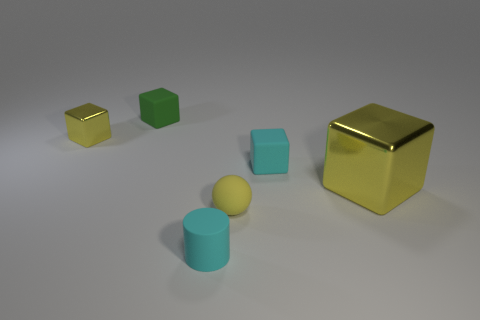Subtract 1 blocks. How many blocks are left? 3 Add 3 tiny cyan things. How many objects exist? 9 Subtract all spheres. How many objects are left? 5 Add 4 big yellow cubes. How many big yellow cubes exist? 5 Subtract 0 brown spheres. How many objects are left? 6 Subtract all tiny green cubes. Subtract all tiny brown cylinders. How many objects are left? 5 Add 5 small yellow metallic blocks. How many small yellow metallic blocks are left? 6 